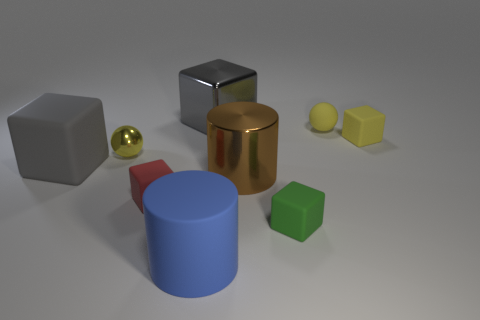There is a large block that is in front of the sphere that is in front of the tiny sphere that is right of the big rubber cylinder; what color is it?
Provide a succinct answer. Gray. Are there any other things that have the same color as the large metallic cylinder?
Offer a terse response. No. What shape is the thing that is the same color as the large metal block?
Offer a very short reply. Cube. What is the size of the blue rubber cylinder to the left of the small green matte block?
Give a very brief answer. Large. There is a yellow rubber object that is the same size as the yellow rubber block; what is its shape?
Give a very brief answer. Sphere. Does the sphere behind the tiny metal thing have the same material as the tiny ball on the left side of the brown object?
Keep it short and to the point. No. What material is the large cube right of the big rubber object that is on the left side of the metallic ball?
Offer a terse response. Metal. What size is the matte sphere to the right of the big cylinder right of the gray block that is behind the small yellow rubber sphere?
Ensure brevity in your answer.  Small. Do the green cube and the matte ball have the same size?
Provide a short and direct response. Yes. There is a matte object to the right of the tiny yellow matte ball; does it have the same shape as the yellow thing that is on the left side of the large brown object?
Provide a succinct answer. No. 